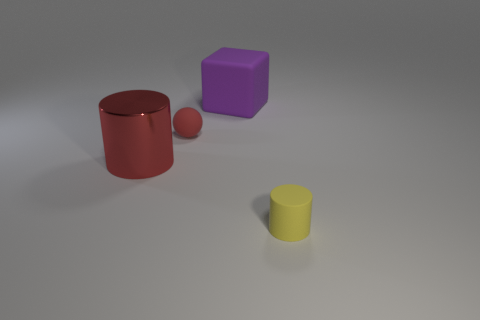There is a ball that is the same color as the big cylinder; what is it made of?
Give a very brief answer. Rubber. Is the size of the cylinder that is to the left of the ball the same as the yellow matte object?
Keep it short and to the point. No. Are there more matte cubes than small purple cylinders?
Your response must be concise. Yes. How many big objects are either purple cubes or red spheres?
Make the answer very short. 1. How many other things are the same color as the sphere?
Offer a very short reply. 1. What number of tiny red things are the same material as the purple cube?
Keep it short and to the point. 1. There is a matte thing that is in front of the red rubber ball; is it the same color as the large metallic object?
Offer a very short reply. No. What number of red things are either tiny objects or big objects?
Your answer should be very brief. 2. Is there any other thing that has the same material as the big cylinder?
Your answer should be very brief. No. Is the material of the big thing that is to the left of the tiny red rubber ball the same as the large purple thing?
Offer a very short reply. No. 